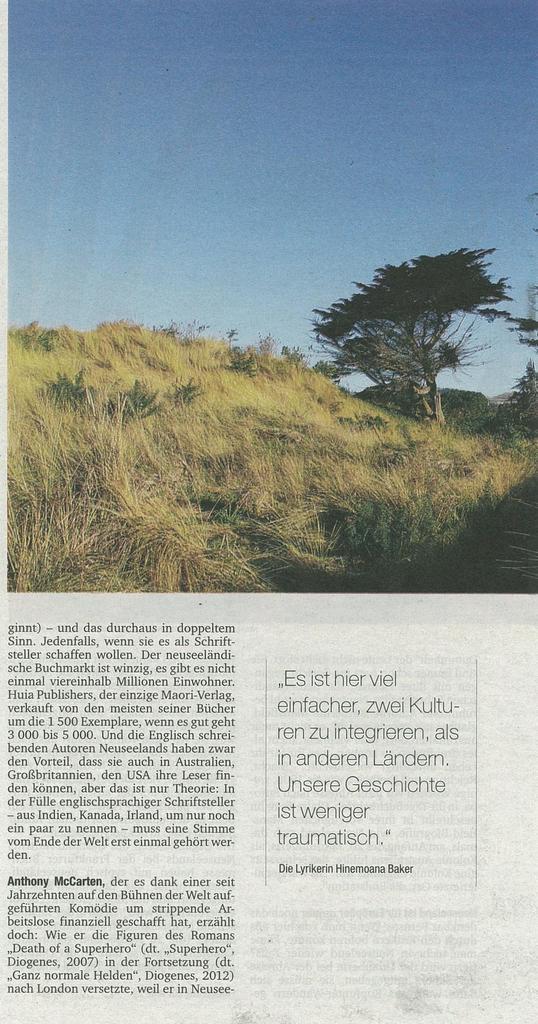Could you give a brief overview of what you see in this image? In this image, we can see an article. Here we can see a picture. In this picture, we can see grass, trees and sky. 